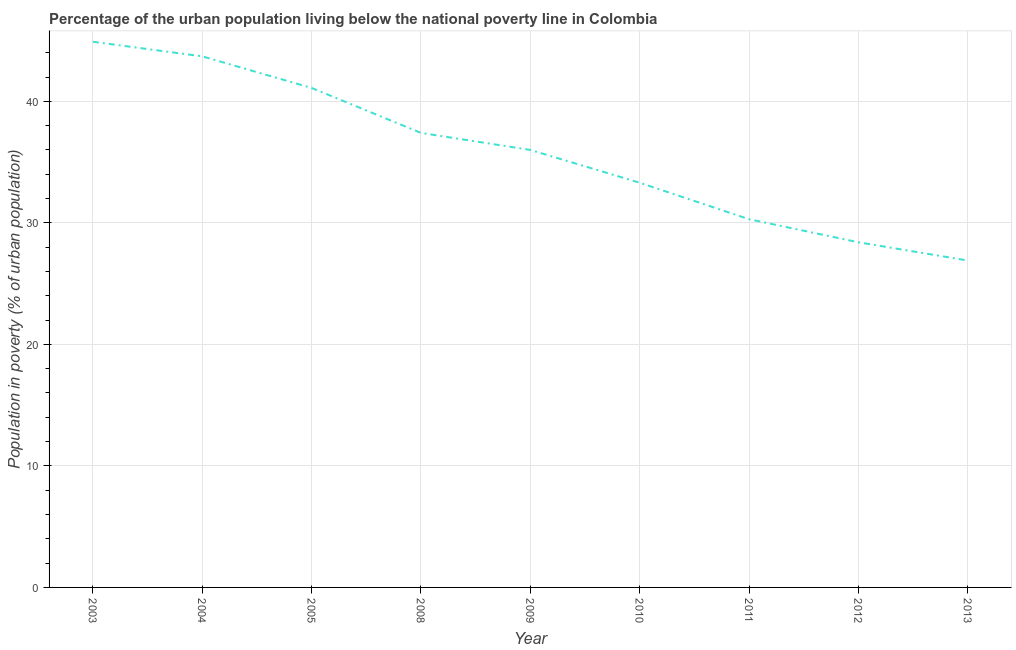What is the percentage of urban population living below poverty line in 2005?
Provide a short and direct response. 41.1. Across all years, what is the maximum percentage of urban population living below poverty line?
Offer a very short reply. 44.9. Across all years, what is the minimum percentage of urban population living below poverty line?
Provide a succinct answer. 26.9. In which year was the percentage of urban population living below poverty line maximum?
Provide a short and direct response. 2003. What is the sum of the percentage of urban population living below poverty line?
Ensure brevity in your answer.  322. What is the difference between the percentage of urban population living below poverty line in 2003 and 2008?
Make the answer very short. 7.5. What is the average percentage of urban population living below poverty line per year?
Your answer should be very brief. 35.78. What is the median percentage of urban population living below poverty line?
Ensure brevity in your answer.  36. Do a majority of the years between 2009 and 2011 (inclusive) have percentage of urban population living below poverty line greater than 32 %?
Your answer should be very brief. Yes. What is the ratio of the percentage of urban population living below poverty line in 2011 to that in 2012?
Your answer should be compact. 1.07. Is the percentage of urban population living below poverty line in 2008 less than that in 2009?
Your response must be concise. No. What is the difference between the highest and the second highest percentage of urban population living below poverty line?
Ensure brevity in your answer.  1.2. Is the sum of the percentage of urban population living below poverty line in 2005 and 2009 greater than the maximum percentage of urban population living below poverty line across all years?
Provide a succinct answer. Yes. In how many years, is the percentage of urban population living below poverty line greater than the average percentage of urban population living below poverty line taken over all years?
Make the answer very short. 5. Does the percentage of urban population living below poverty line monotonically increase over the years?
Offer a very short reply. No. Are the values on the major ticks of Y-axis written in scientific E-notation?
Your answer should be very brief. No. Does the graph contain any zero values?
Your response must be concise. No. What is the title of the graph?
Keep it short and to the point. Percentage of the urban population living below the national poverty line in Colombia. What is the label or title of the Y-axis?
Keep it short and to the point. Population in poverty (% of urban population). What is the Population in poverty (% of urban population) in 2003?
Offer a very short reply. 44.9. What is the Population in poverty (% of urban population) of 2004?
Your answer should be compact. 43.7. What is the Population in poverty (% of urban population) in 2005?
Your answer should be very brief. 41.1. What is the Population in poverty (% of urban population) in 2008?
Make the answer very short. 37.4. What is the Population in poverty (% of urban population) of 2010?
Offer a terse response. 33.3. What is the Population in poverty (% of urban population) of 2011?
Offer a very short reply. 30.3. What is the Population in poverty (% of urban population) in 2012?
Provide a succinct answer. 28.4. What is the Population in poverty (% of urban population) of 2013?
Keep it short and to the point. 26.9. What is the difference between the Population in poverty (% of urban population) in 2003 and 2004?
Your answer should be compact. 1.2. What is the difference between the Population in poverty (% of urban population) in 2003 and 2008?
Offer a very short reply. 7.5. What is the difference between the Population in poverty (% of urban population) in 2003 and 2012?
Your answer should be very brief. 16.5. What is the difference between the Population in poverty (% of urban population) in 2003 and 2013?
Your answer should be compact. 18. What is the difference between the Population in poverty (% of urban population) in 2004 and 2009?
Your answer should be compact. 7.7. What is the difference between the Population in poverty (% of urban population) in 2004 and 2011?
Your answer should be very brief. 13.4. What is the difference between the Population in poverty (% of urban population) in 2004 and 2013?
Offer a very short reply. 16.8. What is the difference between the Population in poverty (% of urban population) in 2005 and 2010?
Offer a very short reply. 7.8. What is the difference between the Population in poverty (% of urban population) in 2005 and 2011?
Keep it short and to the point. 10.8. What is the difference between the Population in poverty (% of urban population) in 2005 and 2013?
Your response must be concise. 14.2. What is the difference between the Population in poverty (% of urban population) in 2008 and 2010?
Provide a succinct answer. 4.1. What is the difference between the Population in poverty (% of urban population) in 2008 and 2011?
Give a very brief answer. 7.1. What is the difference between the Population in poverty (% of urban population) in 2008 and 2012?
Make the answer very short. 9. What is the difference between the Population in poverty (% of urban population) in 2009 and 2011?
Offer a very short reply. 5.7. What is the difference between the Population in poverty (% of urban population) in 2010 and 2013?
Offer a very short reply. 6.4. What is the difference between the Population in poverty (% of urban population) in 2012 and 2013?
Offer a terse response. 1.5. What is the ratio of the Population in poverty (% of urban population) in 2003 to that in 2004?
Your response must be concise. 1.03. What is the ratio of the Population in poverty (% of urban population) in 2003 to that in 2005?
Your response must be concise. 1.09. What is the ratio of the Population in poverty (% of urban population) in 2003 to that in 2008?
Give a very brief answer. 1.2. What is the ratio of the Population in poverty (% of urban population) in 2003 to that in 2009?
Ensure brevity in your answer.  1.25. What is the ratio of the Population in poverty (% of urban population) in 2003 to that in 2010?
Ensure brevity in your answer.  1.35. What is the ratio of the Population in poverty (% of urban population) in 2003 to that in 2011?
Your answer should be very brief. 1.48. What is the ratio of the Population in poverty (% of urban population) in 2003 to that in 2012?
Provide a succinct answer. 1.58. What is the ratio of the Population in poverty (% of urban population) in 2003 to that in 2013?
Give a very brief answer. 1.67. What is the ratio of the Population in poverty (% of urban population) in 2004 to that in 2005?
Provide a succinct answer. 1.06. What is the ratio of the Population in poverty (% of urban population) in 2004 to that in 2008?
Provide a short and direct response. 1.17. What is the ratio of the Population in poverty (% of urban population) in 2004 to that in 2009?
Keep it short and to the point. 1.21. What is the ratio of the Population in poverty (% of urban population) in 2004 to that in 2010?
Offer a very short reply. 1.31. What is the ratio of the Population in poverty (% of urban population) in 2004 to that in 2011?
Your answer should be very brief. 1.44. What is the ratio of the Population in poverty (% of urban population) in 2004 to that in 2012?
Provide a short and direct response. 1.54. What is the ratio of the Population in poverty (% of urban population) in 2004 to that in 2013?
Provide a short and direct response. 1.62. What is the ratio of the Population in poverty (% of urban population) in 2005 to that in 2008?
Make the answer very short. 1.1. What is the ratio of the Population in poverty (% of urban population) in 2005 to that in 2009?
Ensure brevity in your answer.  1.14. What is the ratio of the Population in poverty (% of urban population) in 2005 to that in 2010?
Offer a very short reply. 1.23. What is the ratio of the Population in poverty (% of urban population) in 2005 to that in 2011?
Offer a terse response. 1.36. What is the ratio of the Population in poverty (% of urban population) in 2005 to that in 2012?
Your answer should be very brief. 1.45. What is the ratio of the Population in poverty (% of urban population) in 2005 to that in 2013?
Your answer should be very brief. 1.53. What is the ratio of the Population in poverty (% of urban population) in 2008 to that in 2009?
Provide a short and direct response. 1.04. What is the ratio of the Population in poverty (% of urban population) in 2008 to that in 2010?
Offer a terse response. 1.12. What is the ratio of the Population in poverty (% of urban population) in 2008 to that in 2011?
Your response must be concise. 1.23. What is the ratio of the Population in poverty (% of urban population) in 2008 to that in 2012?
Provide a short and direct response. 1.32. What is the ratio of the Population in poverty (% of urban population) in 2008 to that in 2013?
Your answer should be very brief. 1.39. What is the ratio of the Population in poverty (% of urban population) in 2009 to that in 2010?
Offer a very short reply. 1.08. What is the ratio of the Population in poverty (% of urban population) in 2009 to that in 2011?
Keep it short and to the point. 1.19. What is the ratio of the Population in poverty (% of urban population) in 2009 to that in 2012?
Your answer should be very brief. 1.27. What is the ratio of the Population in poverty (% of urban population) in 2009 to that in 2013?
Give a very brief answer. 1.34. What is the ratio of the Population in poverty (% of urban population) in 2010 to that in 2011?
Offer a terse response. 1.1. What is the ratio of the Population in poverty (% of urban population) in 2010 to that in 2012?
Keep it short and to the point. 1.17. What is the ratio of the Population in poverty (% of urban population) in 2010 to that in 2013?
Make the answer very short. 1.24. What is the ratio of the Population in poverty (% of urban population) in 2011 to that in 2012?
Provide a succinct answer. 1.07. What is the ratio of the Population in poverty (% of urban population) in 2011 to that in 2013?
Keep it short and to the point. 1.13. What is the ratio of the Population in poverty (% of urban population) in 2012 to that in 2013?
Make the answer very short. 1.06. 